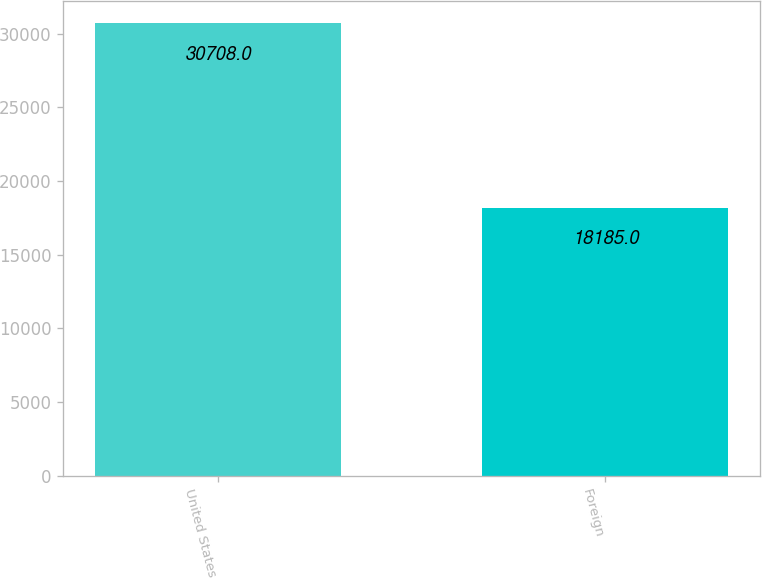Convert chart to OTSL. <chart><loc_0><loc_0><loc_500><loc_500><bar_chart><fcel>United States<fcel>Foreign<nl><fcel>30708<fcel>18185<nl></chart> 